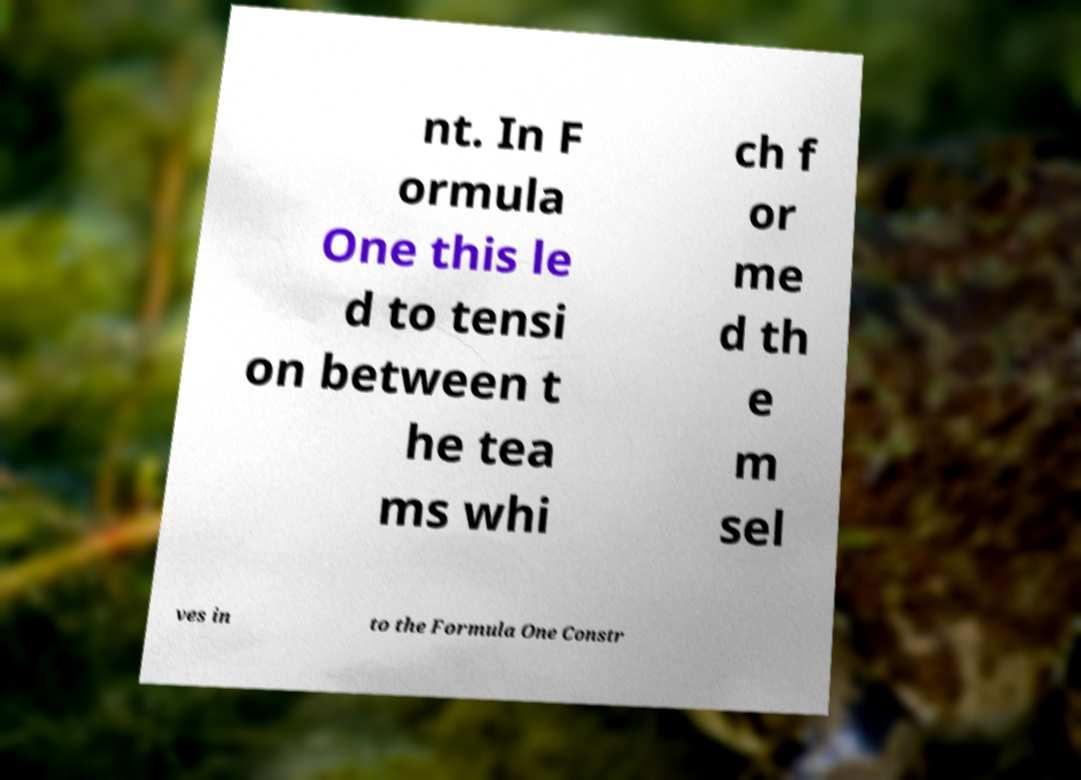Can you accurately transcribe the text from the provided image for me? nt. In F ormula One this le d to tensi on between t he tea ms whi ch f or me d th e m sel ves in to the Formula One Constr 